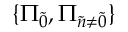Convert formula to latex. <formula><loc_0><loc_0><loc_500><loc_500>\{ \Pi _ { \tilde { 0 } } , \Pi _ { \tilde { n } \neq \tilde { 0 } } \}</formula> 